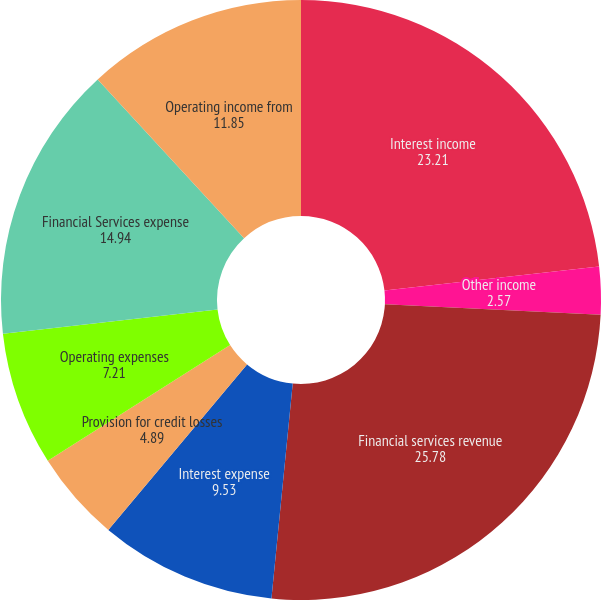<chart> <loc_0><loc_0><loc_500><loc_500><pie_chart><fcel>Interest income<fcel>Other income<fcel>Financial services revenue<fcel>Interest expense<fcel>Provision for credit losses<fcel>Operating expenses<fcel>Financial Services expense<fcel>Operating income from<nl><fcel>23.21%<fcel>2.57%<fcel>25.78%<fcel>9.53%<fcel>4.89%<fcel>7.21%<fcel>14.94%<fcel>11.85%<nl></chart> 